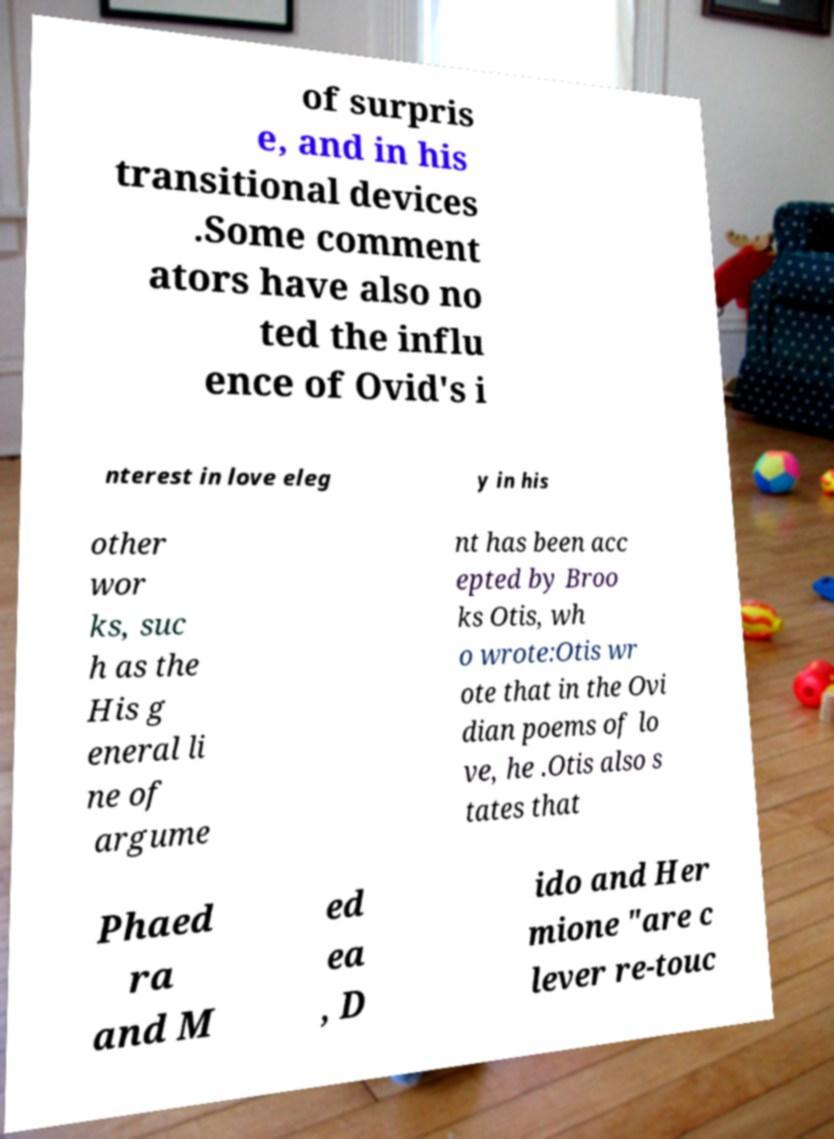What messages or text are displayed in this image? I need them in a readable, typed format. of surpris e, and in his transitional devices .Some comment ators have also no ted the influ ence of Ovid's i nterest in love eleg y in his other wor ks, suc h as the His g eneral li ne of argume nt has been acc epted by Broo ks Otis, wh o wrote:Otis wr ote that in the Ovi dian poems of lo ve, he .Otis also s tates that Phaed ra and M ed ea , D ido and Her mione "are c lever re-touc 